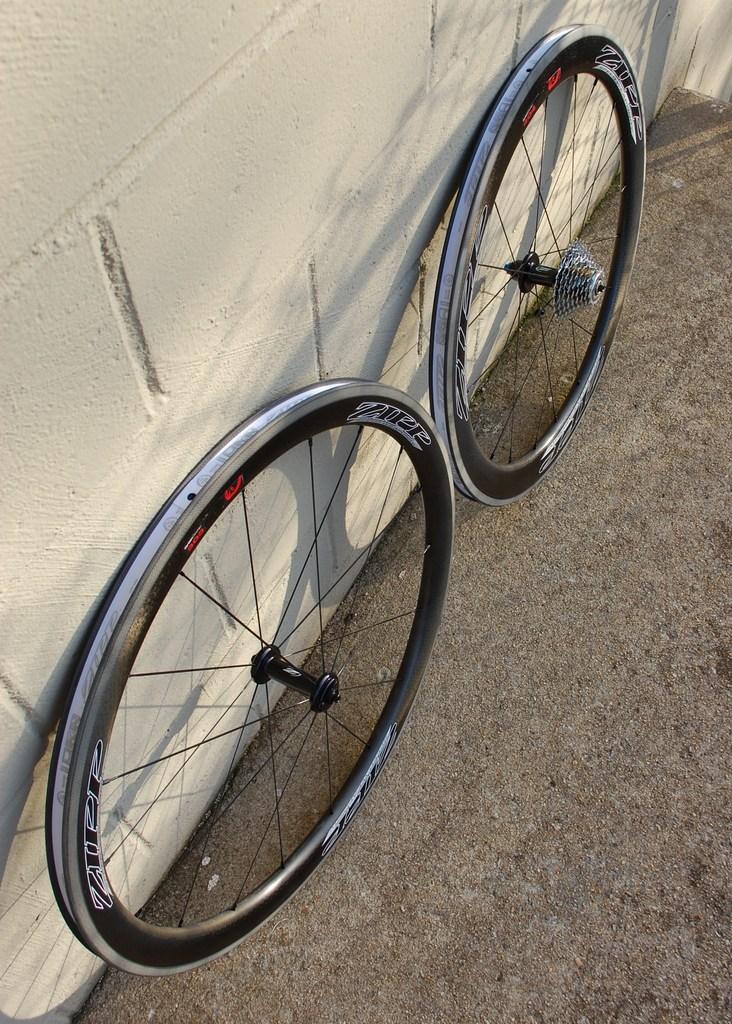Can you describe this image briefly? There are two wheels of a bicycle present on the floor as we can see at the bottom of this image. We can see a wall in the background. 